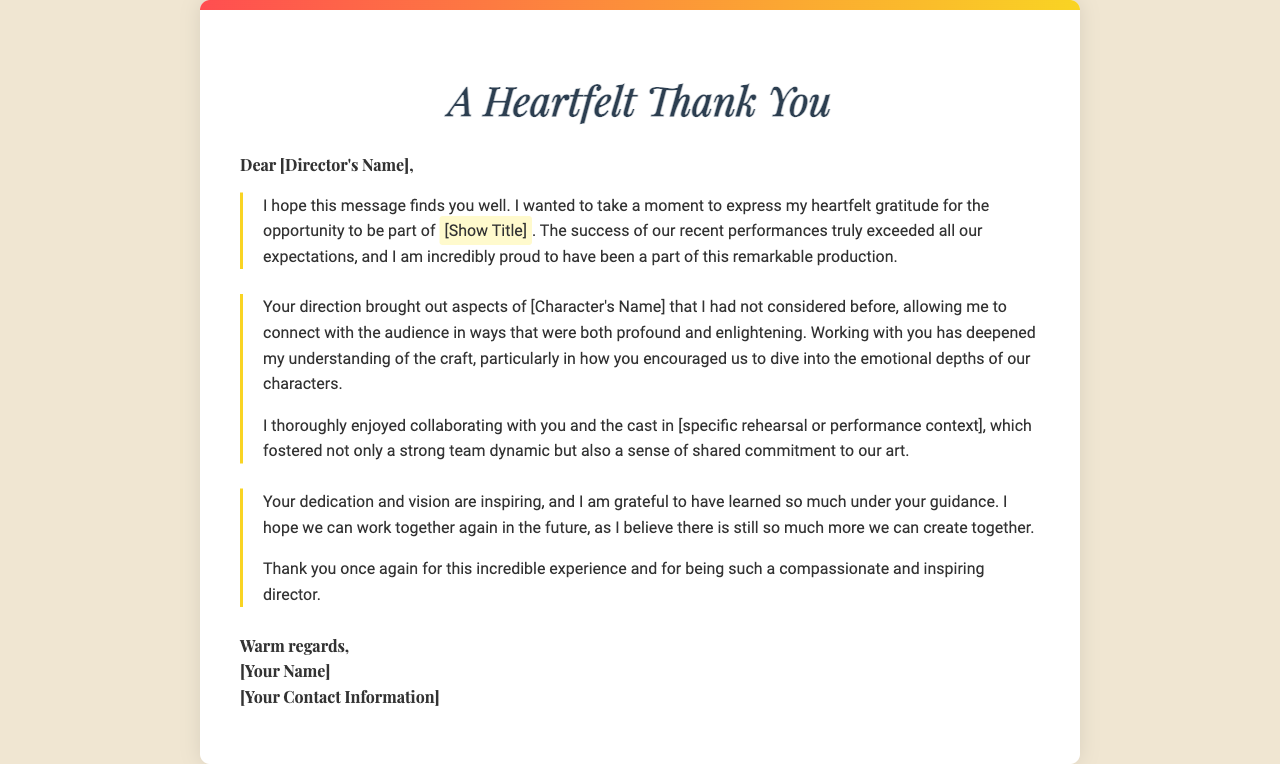what is the title of the show mentioned? The title of the show is referred to within the highlighted section of the letter.
Answer: [Show Title] who is the recipient of the letter? The letter is addressed to a specific person, the director's name is mentioned at the beginning.
Answer: [Director's Name] how does the sender describe their feelings about the performances? The sender uses expressive language to convey their thoughts about the performances and their pride in being part of the production.
Answer: incredibly proud what specific aspect of their character did the director help the sender discover? The letter suggests that the director brought out new aspects of the character that the sender had not considered before.
Answer: aspects of [Character's Name] what do the sender and the director share in apart from the work? The letter mentions a strong dynamic and a sense of commitment that is fostered during their collaboration.
Answer: strong team dynamic what is the sender's hope regarding future collaborations? The sender expresses a desire to work with the director again, indicating they recognize the potential for future projects.
Answer: hope we can work together again how does the sender close the letter? The letter concludes with a farewell, reflecting warmth and respect towards the director.
Answer: Warm regards 